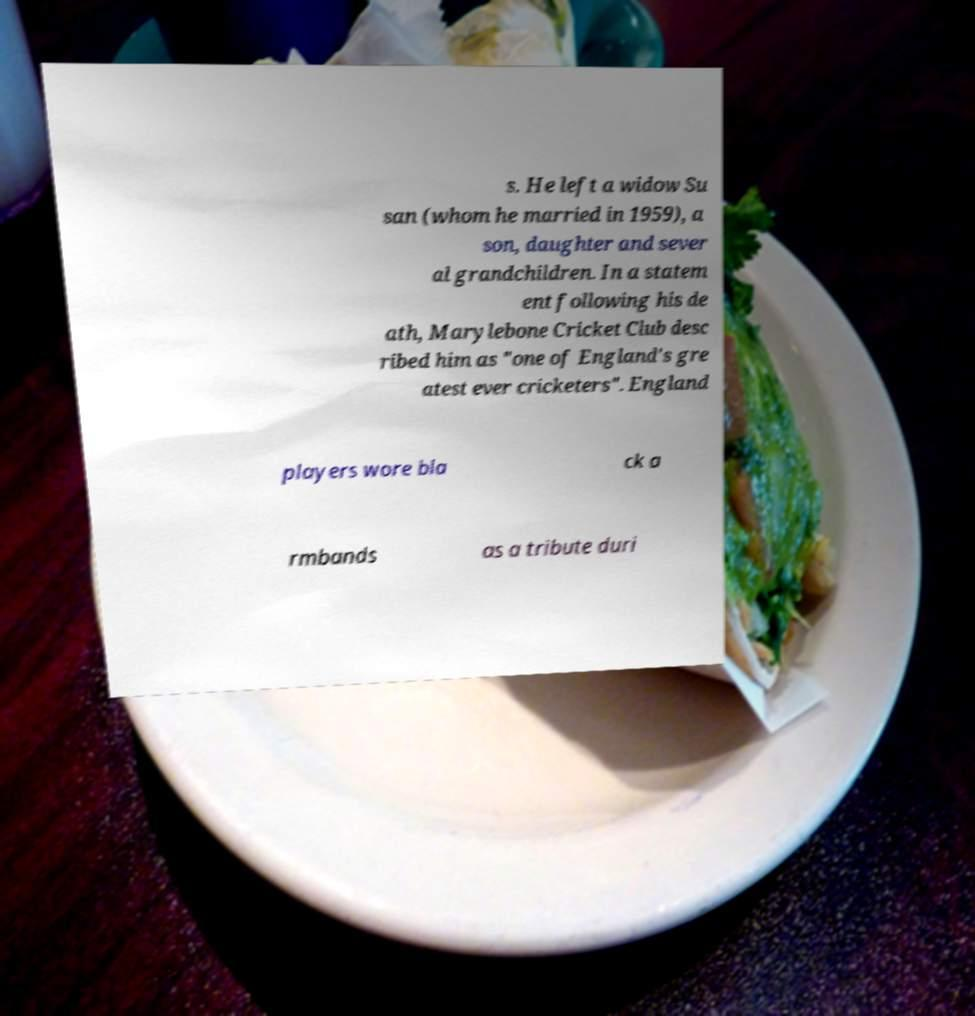Could you assist in decoding the text presented in this image and type it out clearly? s. He left a widow Su san (whom he married in 1959), a son, daughter and sever al grandchildren. In a statem ent following his de ath, Marylebone Cricket Club desc ribed him as "one of England's gre atest ever cricketers". England players wore bla ck a rmbands as a tribute duri 